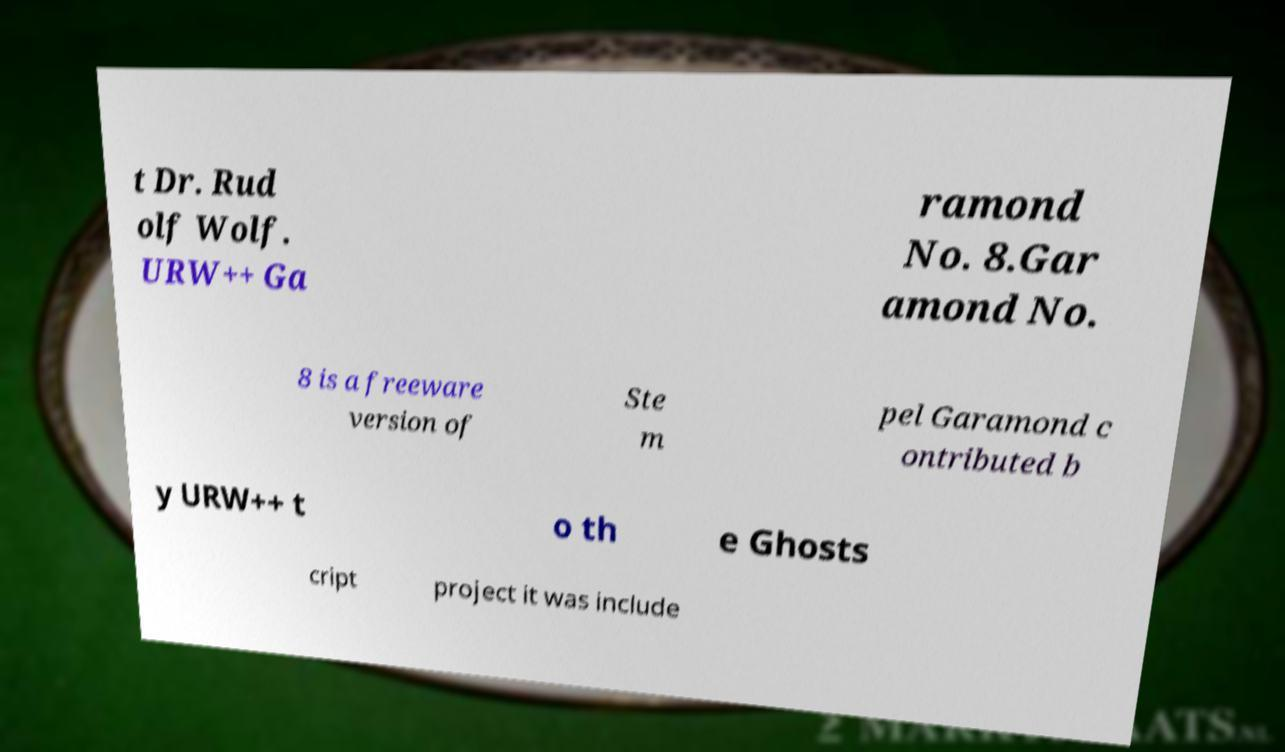There's text embedded in this image that I need extracted. Can you transcribe it verbatim? t Dr. Rud olf Wolf. URW++ Ga ramond No. 8.Gar amond No. 8 is a freeware version of Ste m pel Garamond c ontributed b y URW++ t o th e Ghosts cript project it was include 